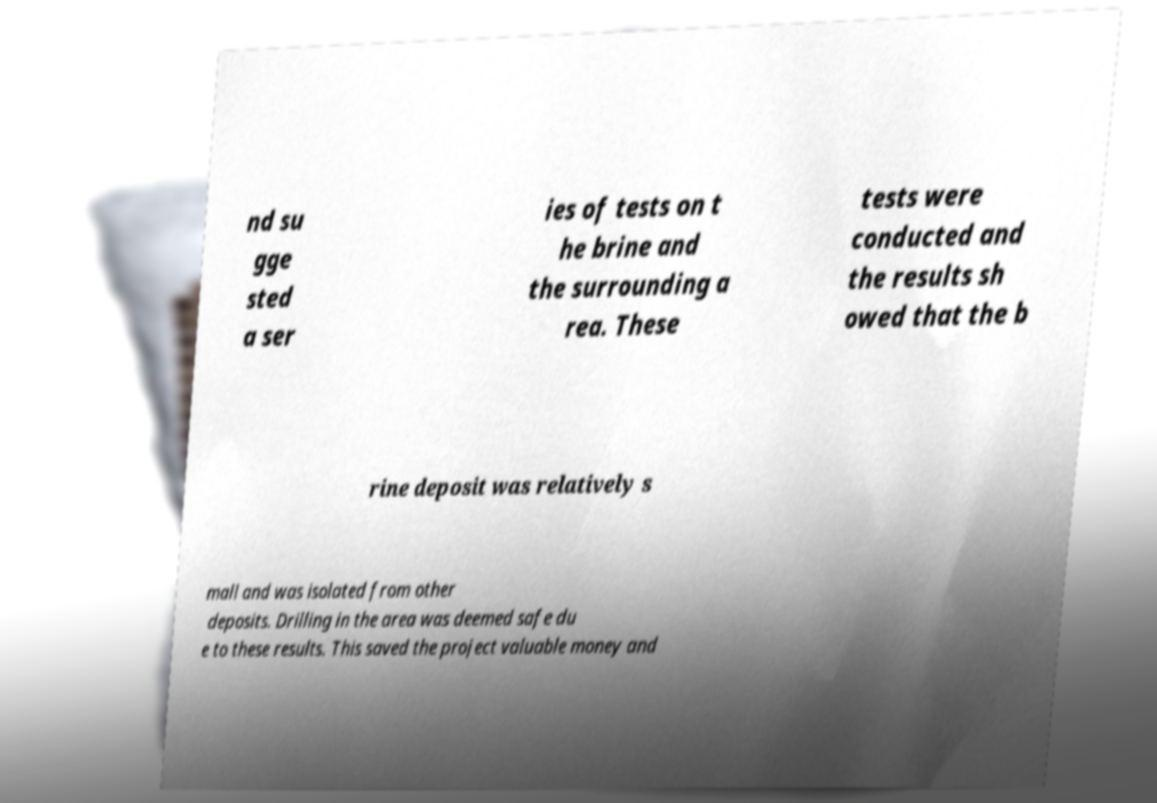Could you assist in decoding the text presented in this image and type it out clearly? nd su gge sted a ser ies of tests on t he brine and the surrounding a rea. These tests were conducted and the results sh owed that the b rine deposit was relatively s mall and was isolated from other deposits. Drilling in the area was deemed safe du e to these results. This saved the project valuable money and 